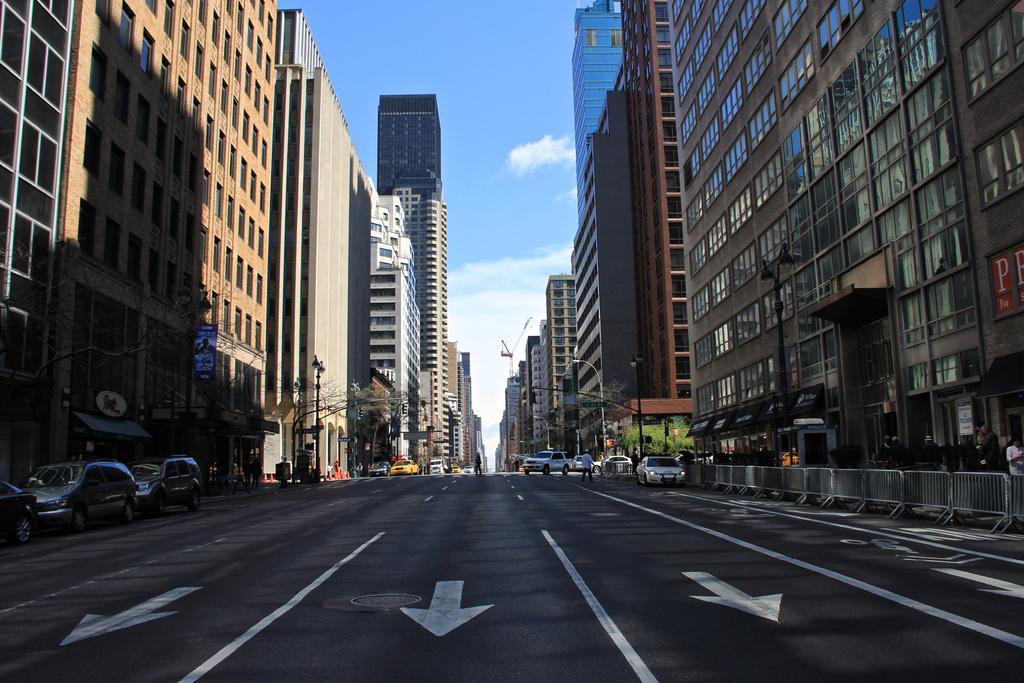Please provide a concise description of this image. In this image I can see buildings, vehicles on the road and people. I can also see poles, trees and fence. In the background I can see the sky. 